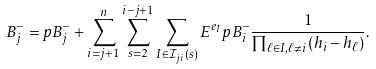Convert formula to latex. <formula><loc_0><loc_0><loc_500><loc_500>B _ { j } ^ { - } = p B _ { j } ^ { - } + \sum _ { i = j + 1 } ^ { n } \sum _ { s = 2 } ^ { i - j + 1 } \sum _ { I \in \mathcal { I } _ { j i } ( s ) } E ^ { e _ { I } } p B _ { i } ^ { - } \frac { 1 } { \prod _ { \ell \in I , \ell \neq i } ( h _ { i } - h _ { \ell } ) } .</formula> 